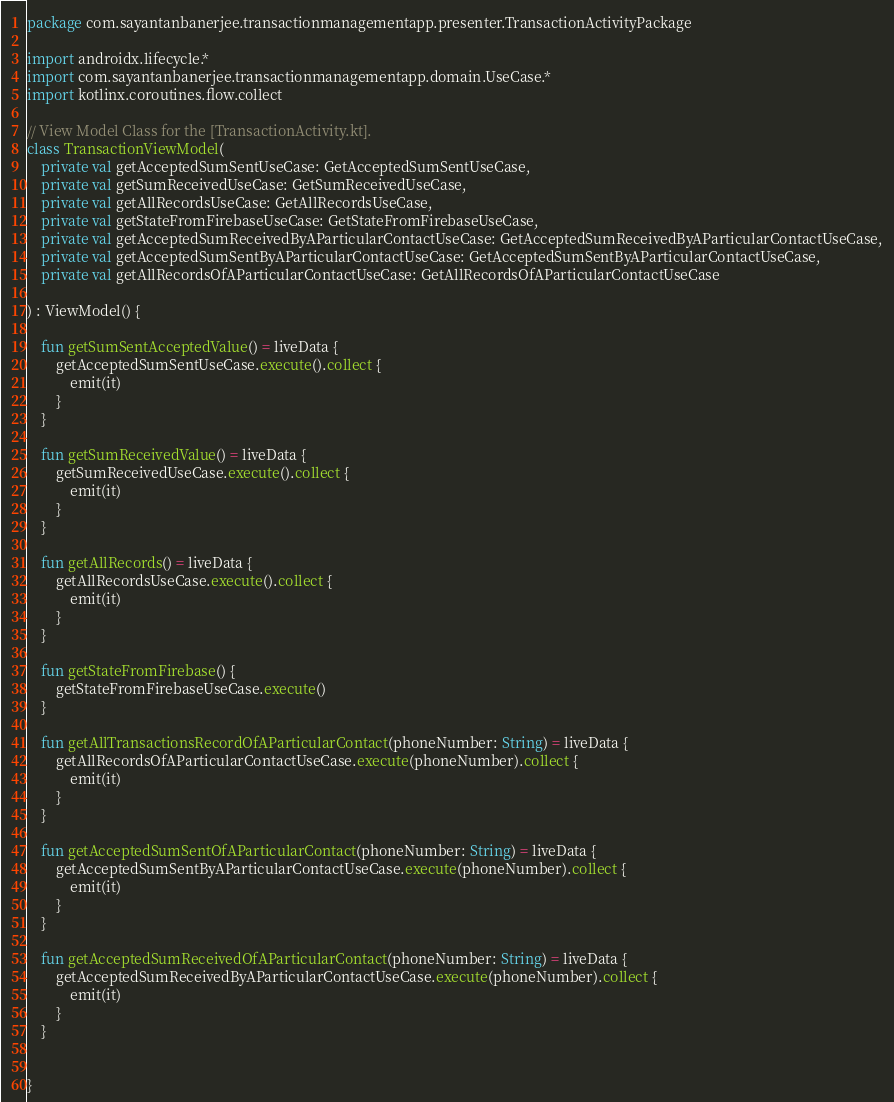<code> <loc_0><loc_0><loc_500><loc_500><_Kotlin_>package com.sayantanbanerjee.transactionmanagementapp.presenter.TransactionActivityPackage

import androidx.lifecycle.*
import com.sayantanbanerjee.transactionmanagementapp.domain.UseCase.*
import kotlinx.coroutines.flow.collect

// View Model Class for the [TransactionActivity.kt].
class TransactionViewModel(
    private val getAcceptedSumSentUseCase: GetAcceptedSumSentUseCase,
    private val getSumReceivedUseCase: GetSumReceivedUseCase,
    private val getAllRecordsUseCase: GetAllRecordsUseCase,
    private val getStateFromFirebaseUseCase: GetStateFromFirebaseUseCase,
    private val getAcceptedSumReceivedByAParticularContactUseCase: GetAcceptedSumReceivedByAParticularContactUseCase,
    private val getAcceptedSumSentByAParticularContactUseCase: GetAcceptedSumSentByAParticularContactUseCase,
    private val getAllRecordsOfAParticularContactUseCase: GetAllRecordsOfAParticularContactUseCase

) : ViewModel() {

    fun getSumSentAcceptedValue() = liveData {
        getAcceptedSumSentUseCase.execute().collect {
            emit(it)
        }
    }

    fun getSumReceivedValue() = liveData {
        getSumReceivedUseCase.execute().collect {
            emit(it)
        }
    }

    fun getAllRecords() = liveData {
        getAllRecordsUseCase.execute().collect {
            emit(it)
        }
    }

    fun getStateFromFirebase() {
        getStateFromFirebaseUseCase.execute()
    }

    fun getAllTransactionsRecordOfAParticularContact(phoneNumber: String) = liveData {
        getAllRecordsOfAParticularContactUseCase.execute(phoneNumber).collect {
            emit(it)
        }
    }

    fun getAcceptedSumSentOfAParticularContact(phoneNumber: String) = liveData {
        getAcceptedSumSentByAParticularContactUseCase.execute(phoneNumber).collect {
            emit(it)
        }
    }

    fun getAcceptedSumReceivedOfAParticularContact(phoneNumber: String) = liveData {
        getAcceptedSumReceivedByAParticularContactUseCase.execute(phoneNumber).collect {
            emit(it)
        }
    }


}
</code> 